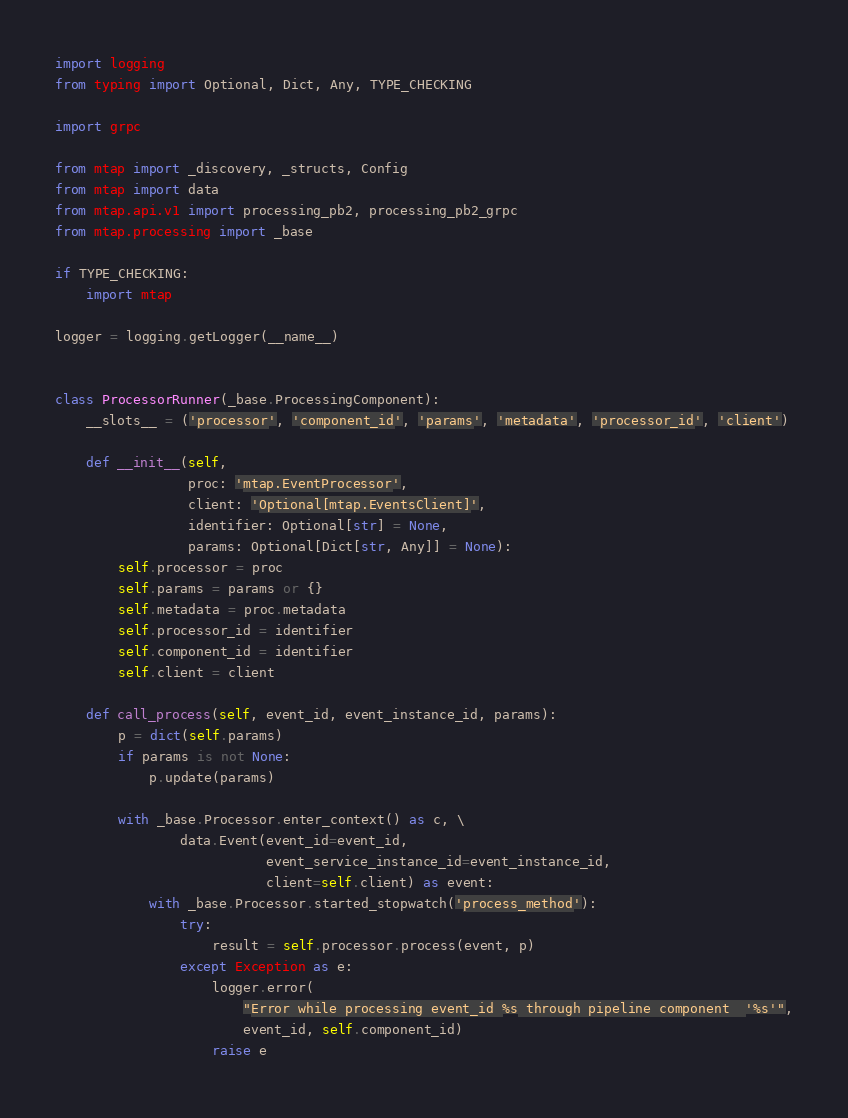Convert code to text. <code><loc_0><loc_0><loc_500><loc_500><_Python_>import logging
from typing import Optional, Dict, Any, TYPE_CHECKING

import grpc

from mtap import _discovery, _structs, Config
from mtap import data
from mtap.api.v1 import processing_pb2, processing_pb2_grpc
from mtap.processing import _base

if TYPE_CHECKING:
    import mtap

logger = logging.getLogger(__name__)


class ProcessorRunner(_base.ProcessingComponent):
    __slots__ = ('processor', 'component_id', 'params', 'metadata', 'processor_id', 'client')

    def __init__(self,
                 proc: 'mtap.EventProcessor',
                 client: 'Optional[mtap.EventsClient]',
                 identifier: Optional[str] = None,
                 params: Optional[Dict[str, Any]] = None):
        self.processor = proc
        self.params = params or {}
        self.metadata = proc.metadata
        self.processor_id = identifier
        self.component_id = identifier
        self.client = client

    def call_process(self, event_id, event_instance_id, params):
        p = dict(self.params)
        if params is not None:
            p.update(params)

        with _base.Processor.enter_context() as c, \
                data.Event(event_id=event_id,
                           event_service_instance_id=event_instance_id,
                           client=self.client) as event:
            with _base.Processor.started_stopwatch('process_method'):
                try:
                    result = self.processor.process(event, p)
                except Exception as e:
                    logger.error(
                        "Error while processing event_id %s through pipeline component  '%s'",
                        event_id, self.component_id)
                    raise e</code> 